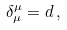<formula> <loc_0><loc_0><loc_500><loc_500>\delta _ { \mu } ^ { \mu } = d \, ,</formula> 